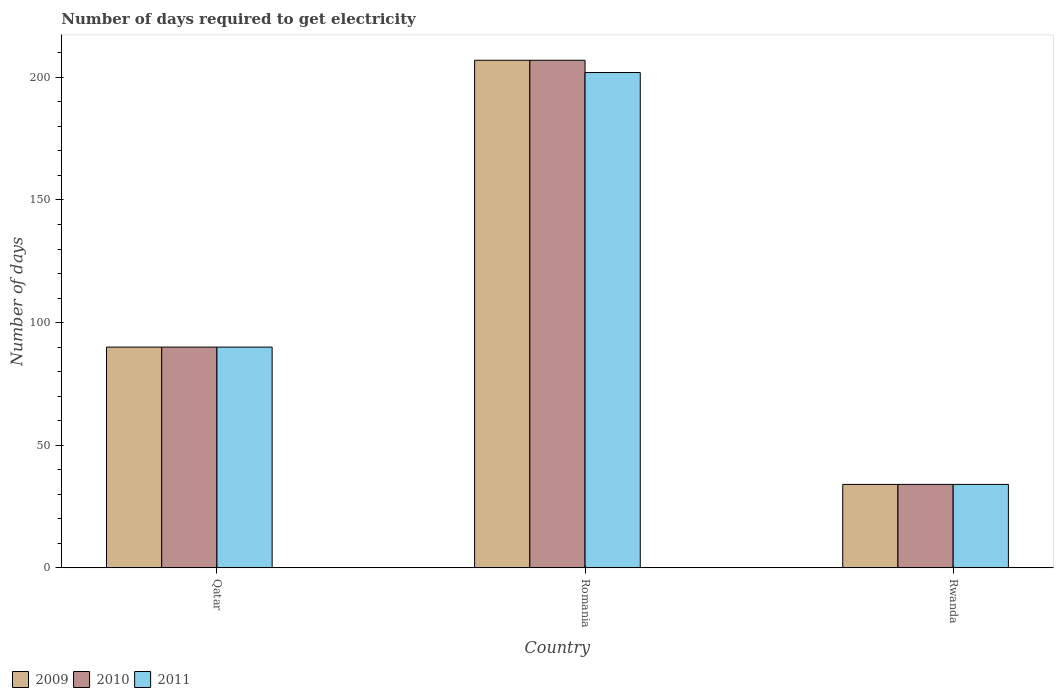Are the number of bars on each tick of the X-axis equal?
Ensure brevity in your answer.  Yes. What is the label of the 3rd group of bars from the left?
Your response must be concise. Rwanda. In how many cases, is the number of bars for a given country not equal to the number of legend labels?
Offer a terse response. 0. What is the number of days required to get electricity in in 2011 in Rwanda?
Ensure brevity in your answer.  34. Across all countries, what is the maximum number of days required to get electricity in in 2011?
Keep it short and to the point. 202. In which country was the number of days required to get electricity in in 2011 maximum?
Ensure brevity in your answer.  Romania. In which country was the number of days required to get electricity in in 2010 minimum?
Your answer should be very brief. Rwanda. What is the total number of days required to get electricity in in 2011 in the graph?
Your answer should be compact. 326. What is the difference between the number of days required to get electricity in in 2011 in Qatar and that in Rwanda?
Provide a short and direct response. 56. What is the average number of days required to get electricity in in 2011 per country?
Provide a short and direct response. 108.67. What is the ratio of the number of days required to get electricity in in 2009 in Romania to that in Rwanda?
Ensure brevity in your answer.  6.09. Is the number of days required to get electricity in in 2009 in Qatar less than that in Romania?
Offer a very short reply. Yes. What is the difference between the highest and the lowest number of days required to get electricity in in 2011?
Your answer should be very brief. 168. Is the sum of the number of days required to get electricity in in 2009 in Romania and Rwanda greater than the maximum number of days required to get electricity in in 2011 across all countries?
Provide a short and direct response. Yes. Is it the case that in every country, the sum of the number of days required to get electricity in in 2009 and number of days required to get electricity in in 2010 is greater than the number of days required to get electricity in in 2011?
Your answer should be very brief. Yes. Are the values on the major ticks of Y-axis written in scientific E-notation?
Provide a succinct answer. No. Does the graph contain grids?
Your response must be concise. No. Where does the legend appear in the graph?
Your response must be concise. Bottom left. What is the title of the graph?
Offer a terse response. Number of days required to get electricity. What is the label or title of the X-axis?
Provide a succinct answer. Country. What is the label or title of the Y-axis?
Offer a very short reply. Number of days. What is the Number of days of 2009 in Qatar?
Offer a very short reply. 90. What is the Number of days of 2010 in Qatar?
Your answer should be compact. 90. What is the Number of days in 2011 in Qatar?
Ensure brevity in your answer.  90. What is the Number of days of 2009 in Romania?
Offer a terse response. 207. What is the Number of days of 2010 in Romania?
Provide a succinct answer. 207. What is the Number of days in 2011 in Romania?
Your response must be concise. 202. What is the Number of days in 2009 in Rwanda?
Ensure brevity in your answer.  34. Across all countries, what is the maximum Number of days of 2009?
Give a very brief answer. 207. Across all countries, what is the maximum Number of days of 2010?
Offer a terse response. 207. Across all countries, what is the maximum Number of days of 2011?
Give a very brief answer. 202. Across all countries, what is the minimum Number of days in 2009?
Keep it short and to the point. 34. Across all countries, what is the minimum Number of days of 2011?
Offer a very short reply. 34. What is the total Number of days of 2009 in the graph?
Give a very brief answer. 331. What is the total Number of days of 2010 in the graph?
Give a very brief answer. 331. What is the total Number of days of 2011 in the graph?
Ensure brevity in your answer.  326. What is the difference between the Number of days of 2009 in Qatar and that in Romania?
Ensure brevity in your answer.  -117. What is the difference between the Number of days in 2010 in Qatar and that in Romania?
Ensure brevity in your answer.  -117. What is the difference between the Number of days in 2011 in Qatar and that in Romania?
Your response must be concise. -112. What is the difference between the Number of days of 2010 in Qatar and that in Rwanda?
Your answer should be very brief. 56. What is the difference between the Number of days of 2009 in Romania and that in Rwanda?
Your answer should be compact. 173. What is the difference between the Number of days in 2010 in Romania and that in Rwanda?
Your response must be concise. 173. What is the difference between the Number of days of 2011 in Romania and that in Rwanda?
Your answer should be compact. 168. What is the difference between the Number of days in 2009 in Qatar and the Number of days in 2010 in Romania?
Your answer should be very brief. -117. What is the difference between the Number of days in 2009 in Qatar and the Number of days in 2011 in Romania?
Give a very brief answer. -112. What is the difference between the Number of days of 2010 in Qatar and the Number of days of 2011 in Romania?
Make the answer very short. -112. What is the difference between the Number of days in 2009 in Qatar and the Number of days in 2010 in Rwanda?
Keep it short and to the point. 56. What is the difference between the Number of days of 2010 in Qatar and the Number of days of 2011 in Rwanda?
Keep it short and to the point. 56. What is the difference between the Number of days of 2009 in Romania and the Number of days of 2010 in Rwanda?
Provide a short and direct response. 173. What is the difference between the Number of days in 2009 in Romania and the Number of days in 2011 in Rwanda?
Provide a short and direct response. 173. What is the difference between the Number of days in 2010 in Romania and the Number of days in 2011 in Rwanda?
Make the answer very short. 173. What is the average Number of days of 2009 per country?
Give a very brief answer. 110.33. What is the average Number of days in 2010 per country?
Your answer should be very brief. 110.33. What is the average Number of days in 2011 per country?
Provide a short and direct response. 108.67. What is the difference between the Number of days of 2009 and Number of days of 2010 in Qatar?
Provide a short and direct response. 0. What is the difference between the Number of days of 2009 and Number of days of 2010 in Rwanda?
Give a very brief answer. 0. What is the difference between the Number of days of 2009 and Number of days of 2011 in Rwanda?
Make the answer very short. 0. What is the ratio of the Number of days in 2009 in Qatar to that in Romania?
Your answer should be compact. 0.43. What is the ratio of the Number of days of 2010 in Qatar to that in Romania?
Your response must be concise. 0.43. What is the ratio of the Number of days in 2011 in Qatar to that in Romania?
Provide a succinct answer. 0.45. What is the ratio of the Number of days of 2009 in Qatar to that in Rwanda?
Ensure brevity in your answer.  2.65. What is the ratio of the Number of days of 2010 in Qatar to that in Rwanda?
Keep it short and to the point. 2.65. What is the ratio of the Number of days of 2011 in Qatar to that in Rwanda?
Your response must be concise. 2.65. What is the ratio of the Number of days of 2009 in Romania to that in Rwanda?
Ensure brevity in your answer.  6.09. What is the ratio of the Number of days of 2010 in Romania to that in Rwanda?
Your response must be concise. 6.09. What is the ratio of the Number of days of 2011 in Romania to that in Rwanda?
Offer a very short reply. 5.94. What is the difference between the highest and the second highest Number of days in 2009?
Your answer should be compact. 117. What is the difference between the highest and the second highest Number of days of 2010?
Your answer should be very brief. 117. What is the difference between the highest and the second highest Number of days in 2011?
Your answer should be compact. 112. What is the difference between the highest and the lowest Number of days in 2009?
Offer a very short reply. 173. What is the difference between the highest and the lowest Number of days in 2010?
Make the answer very short. 173. What is the difference between the highest and the lowest Number of days in 2011?
Your answer should be very brief. 168. 